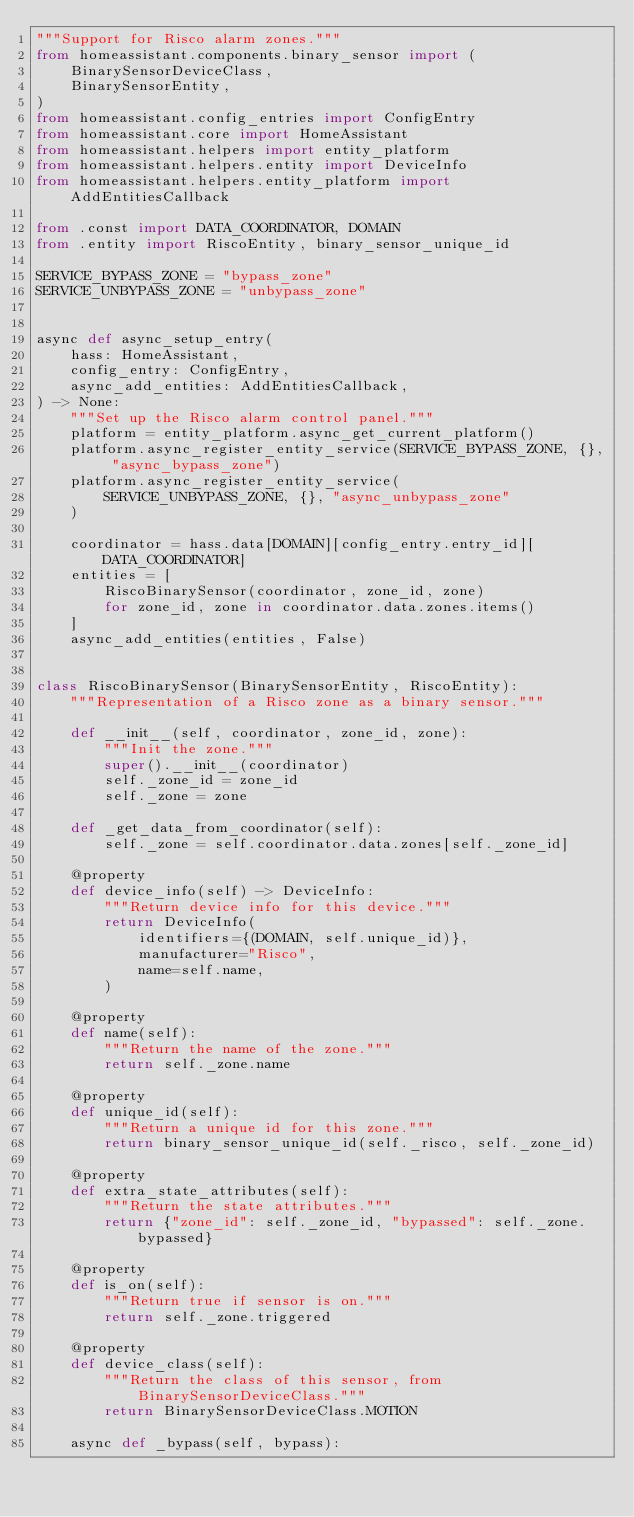<code> <loc_0><loc_0><loc_500><loc_500><_Python_>"""Support for Risco alarm zones."""
from homeassistant.components.binary_sensor import (
    BinarySensorDeviceClass,
    BinarySensorEntity,
)
from homeassistant.config_entries import ConfigEntry
from homeassistant.core import HomeAssistant
from homeassistant.helpers import entity_platform
from homeassistant.helpers.entity import DeviceInfo
from homeassistant.helpers.entity_platform import AddEntitiesCallback

from .const import DATA_COORDINATOR, DOMAIN
from .entity import RiscoEntity, binary_sensor_unique_id

SERVICE_BYPASS_ZONE = "bypass_zone"
SERVICE_UNBYPASS_ZONE = "unbypass_zone"


async def async_setup_entry(
    hass: HomeAssistant,
    config_entry: ConfigEntry,
    async_add_entities: AddEntitiesCallback,
) -> None:
    """Set up the Risco alarm control panel."""
    platform = entity_platform.async_get_current_platform()
    platform.async_register_entity_service(SERVICE_BYPASS_ZONE, {}, "async_bypass_zone")
    platform.async_register_entity_service(
        SERVICE_UNBYPASS_ZONE, {}, "async_unbypass_zone"
    )

    coordinator = hass.data[DOMAIN][config_entry.entry_id][DATA_COORDINATOR]
    entities = [
        RiscoBinarySensor(coordinator, zone_id, zone)
        for zone_id, zone in coordinator.data.zones.items()
    ]
    async_add_entities(entities, False)


class RiscoBinarySensor(BinarySensorEntity, RiscoEntity):
    """Representation of a Risco zone as a binary sensor."""

    def __init__(self, coordinator, zone_id, zone):
        """Init the zone."""
        super().__init__(coordinator)
        self._zone_id = zone_id
        self._zone = zone

    def _get_data_from_coordinator(self):
        self._zone = self.coordinator.data.zones[self._zone_id]

    @property
    def device_info(self) -> DeviceInfo:
        """Return device info for this device."""
        return DeviceInfo(
            identifiers={(DOMAIN, self.unique_id)},
            manufacturer="Risco",
            name=self.name,
        )

    @property
    def name(self):
        """Return the name of the zone."""
        return self._zone.name

    @property
    def unique_id(self):
        """Return a unique id for this zone."""
        return binary_sensor_unique_id(self._risco, self._zone_id)

    @property
    def extra_state_attributes(self):
        """Return the state attributes."""
        return {"zone_id": self._zone_id, "bypassed": self._zone.bypassed}

    @property
    def is_on(self):
        """Return true if sensor is on."""
        return self._zone.triggered

    @property
    def device_class(self):
        """Return the class of this sensor, from BinarySensorDeviceClass."""
        return BinarySensorDeviceClass.MOTION

    async def _bypass(self, bypass):</code> 